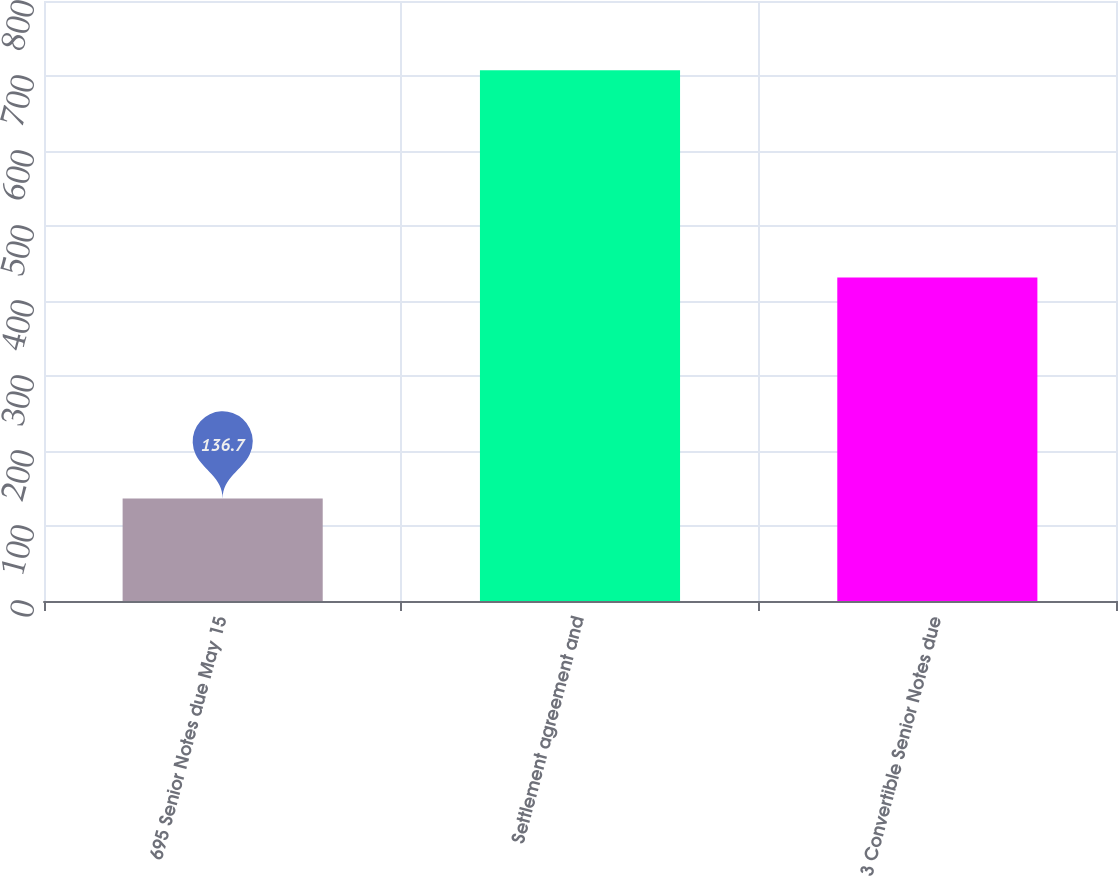Convert chart to OTSL. <chart><loc_0><loc_0><loc_500><loc_500><bar_chart><fcel>695 Senior Notes due May 15<fcel>Settlement agreement and<fcel>3 Convertible Senior Notes due<nl><fcel>136.7<fcel>707.8<fcel>431.3<nl></chart> 